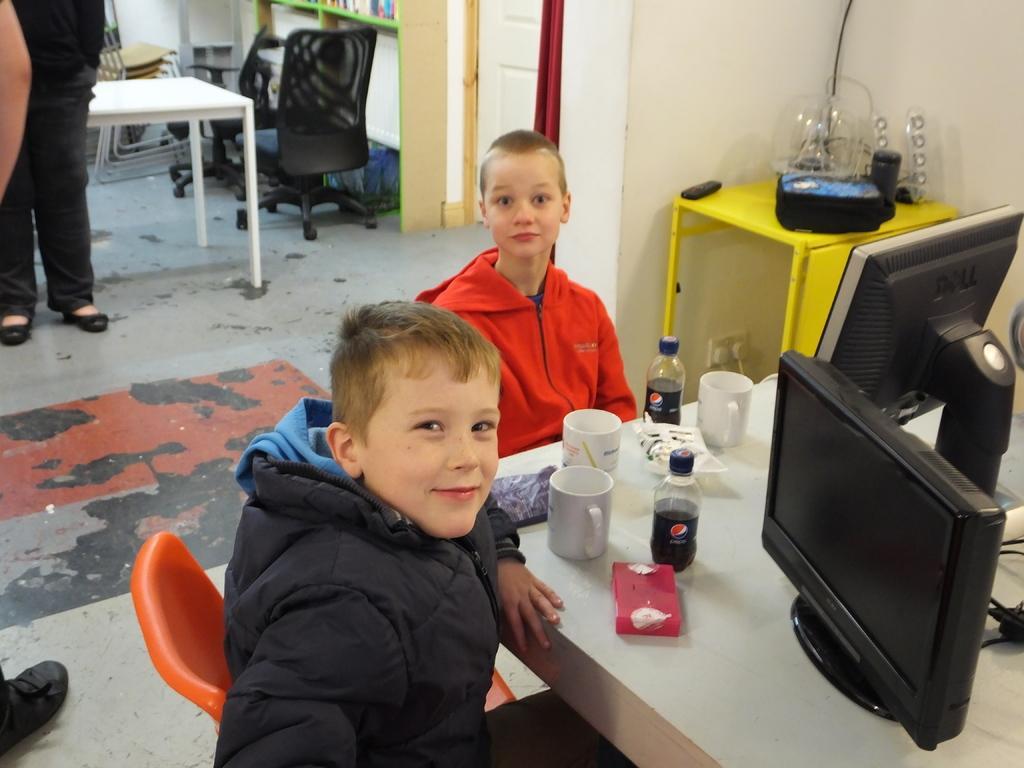Please provide a concise description of this image. In this image we can see this children are sitting on the chairs near the table. There are cups, bottles and monitors on the table. In the background we can see a door, chairs, and a person standing. 